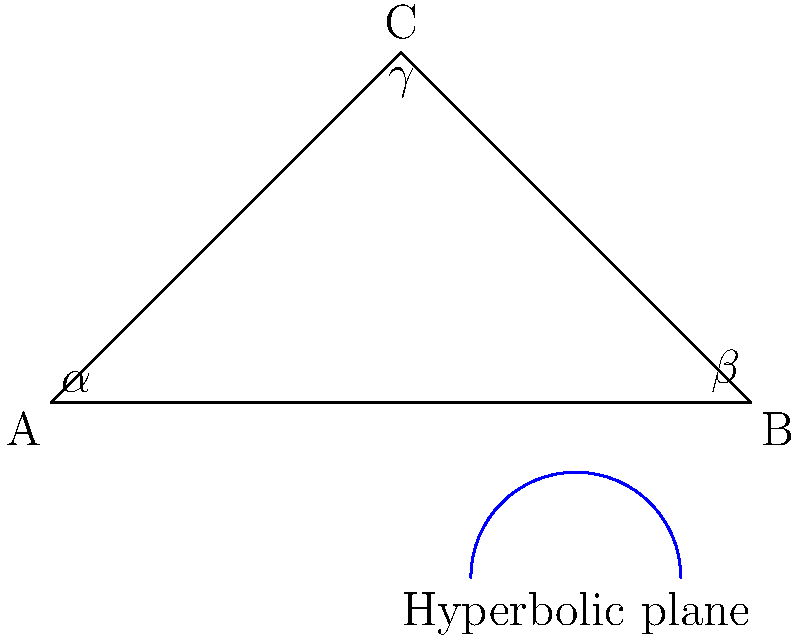In a hyperbolic triangle ABC, the angles are $\alpha$, $\beta$, and $\gamma$. How does the sum of these angles compare to the sum of angles in a Euclidean triangle, and what does this imply about the geometry of space? 1. In Euclidean geometry, the sum of angles in a triangle is always 180°.

2. In hyperbolic geometry, the sum of angles in a triangle is always less than 180°.

3. The difference between 180° and the sum of angles in a hyperbolic triangle is called the defect: $\delta = 180° - (\alpha + \beta + \gamma)$

4. The defect is directly proportional to the area of the hyperbolic triangle: $\text{Area} = k\delta$, where $k$ is a constant depending on the curvature of the hyperbolic plane.

5. This implies that in hyperbolic geometry:
   - Larger triangles have a greater defect
   - The sum of angles decreases as the triangle's size increases
   - There is no such thing as similar triangles (except for congruent ones)

6. The existence of hyperbolic geometry implies that space can have negative curvature, challenging our intuitive understanding of geometry and opening up new possibilities in mathematics and physics.
Answer: Sum of angles $< 180°$; implies negatively curved space 